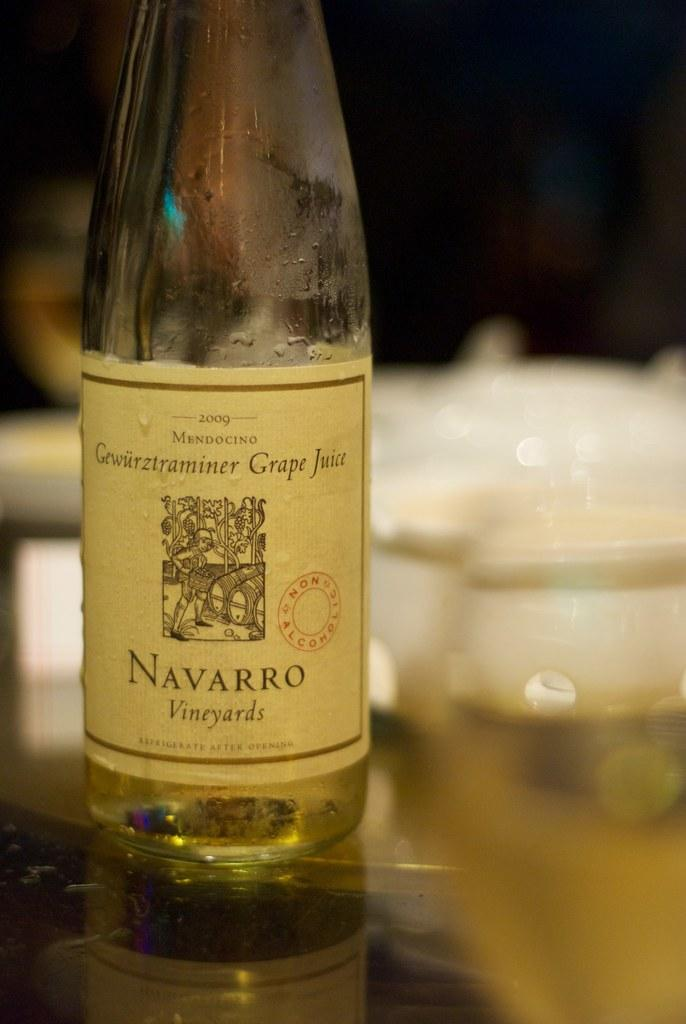<image>
Summarize the visual content of the image. A bottle of wine from Navarro Vineyards says "grape juice" on it. 